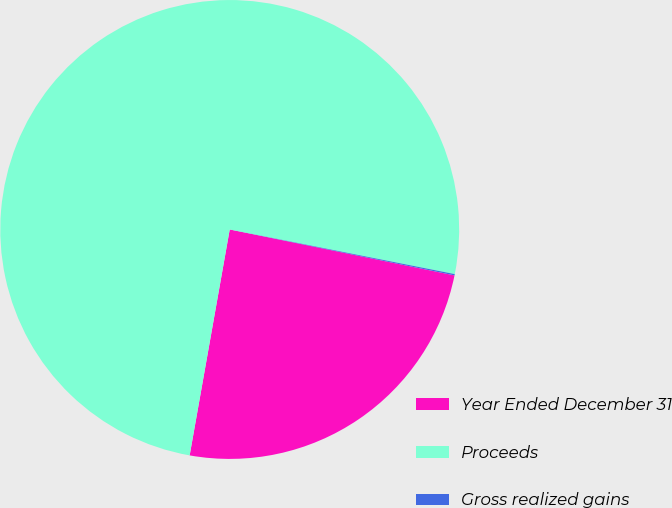<chart> <loc_0><loc_0><loc_500><loc_500><pie_chart><fcel>Year Ended December 31<fcel>Proceeds<fcel>Gross realized gains<nl><fcel>24.59%<fcel>75.33%<fcel>0.09%<nl></chart> 